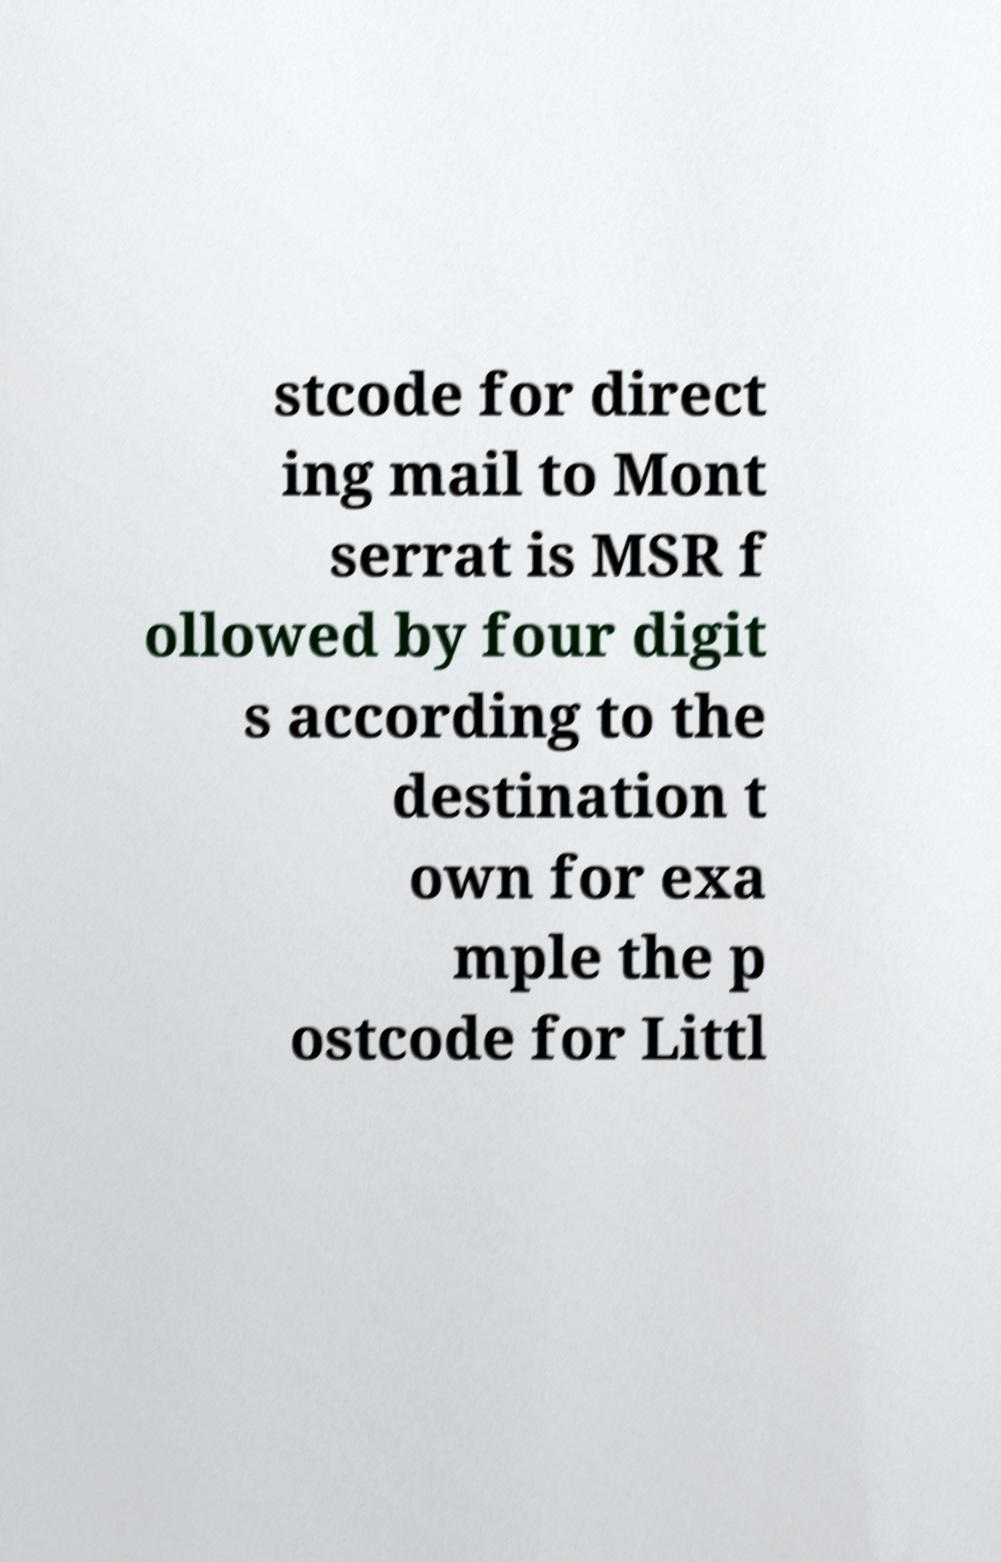Please identify and transcribe the text found in this image. stcode for direct ing mail to Mont serrat is MSR f ollowed by four digit s according to the destination t own for exa mple the p ostcode for Littl 